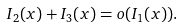Convert formula to latex. <formula><loc_0><loc_0><loc_500><loc_500>I _ { 2 } ( x ) + I _ { 3 } ( x ) = o ( I _ { 1 } ( x ) ) .</formula> 